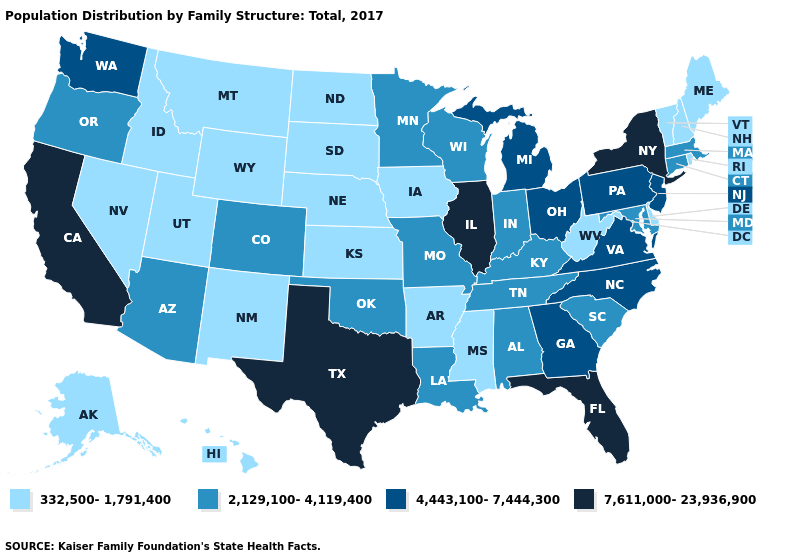Name the states that have a value in the range 4,443,100-7,444,300?
Keep it brief. Georgia, Michigan, New Jersey, North Carolina, Ohio, Pennsylvania, Virginia, Washington. What is the highest value in the MidWest ?
Keep it brief. 7,611,000-23,936,900. Does Washington have a lower value than New York?
Quick response, please. Yes. Name the states that have a value in the range 7,611,000-23,936,900?
Quick response, please. California, Florida, Illinois, New York, Texas. What is the lowest value in the USA?
Write a very short answer. 332,500-1,791,400. Name the states that have a value in the range 7,611,000-23,936,900?
Concise answer only. California, Florida, Illinois, New York, Texas. Among the states that border Massachusetts , which have the highest value?
Give a very brief answer. New York. Is the legend a continuous bar?
Be succinct. No. Name the states that have a value in the range 2,129,100-4,119,400?
Short answer required. Alabama, Arizona, Colorado, Connecticut, Indiana, Kentucky, Louisiana, Maryland, Massachusetts, Minnesota, Missouri, Oklahoma, Oregon, South Carolina, Tennessee, Wisconsin. Does the first symbol in the legend represent the smallest category?
Write a very short answer. Yes. Is the legend a continuous bar?
Give a very brief answer. No. Among the states that border Wisconsin , does Iowa have the lowest value?
Concise answer only. Yes. Does the map have missing data?
Quick response, please. No. Among the states that border Washington , which have the lowest value?
Keep it brief. Idaho. 